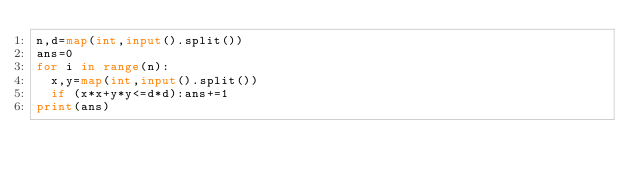Convert code to text. <code><loc_0><loc_0><loc_500><loc_500><_Python_>n,d=map(int,input().split())
ans=0
for i in range(n):
  x,y=map(int,input().split())
  if (x*x+y*y<=d*d):ans+=1
print(ans)</code> 